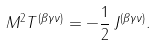<formula> <loc_0><loc_0><loc_500><loc_500>M ^ { 2 } T ^ { ( \beta \gamma \nu ) } = - \frac { 1 } { 2 } \, J ^ { ( \beta \gamma \nu ) } .</formula> 